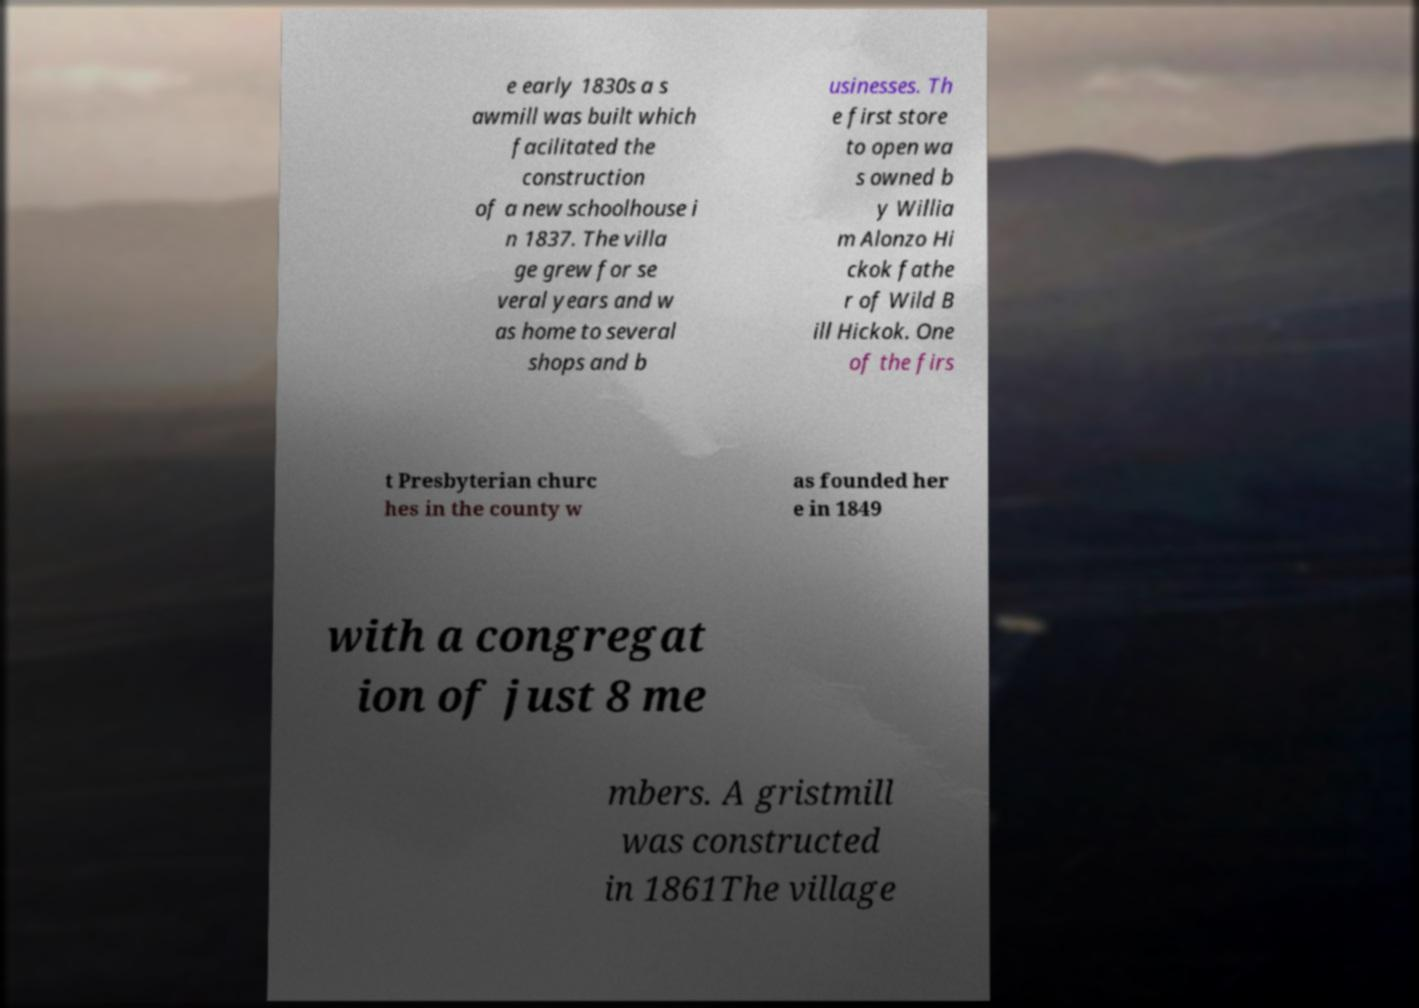Can you accurately transcribe the text from the provided image for me? e early 1830s a s awmill was built which facilitated the construction of a new schoolhouse i n 1837. The villa ge grew for se veral years and w as home to several shops and b usinesses. Th e first store to open wa s owned b y Willia m Alonzo Hi ckok fathe r of Wild B ill Hickok. One of the firs t Presbyterian churc hes in the county w as founded her e in 1849 with a congregat ion of just 8 me mbers. A gristmill was constructed in 1861The village 